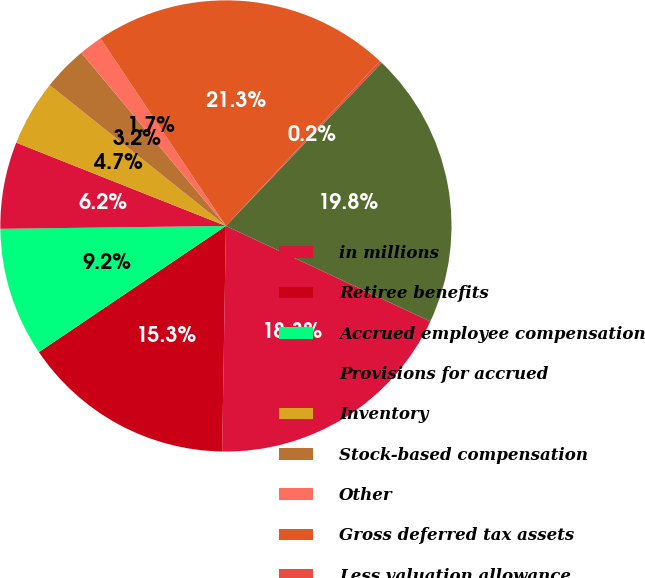Convert chart to OTSL. <chart><loc_0><loc_0><loc_500><loc_500><pie_chart><fcel>in millions<fcel>Retiree benefits<fcel>Accrued employee compensation<fcel>Provisions for accrued<fcel>Inventory<fcel>Stock-based compensation<fcel>Other<fcel>Gross deferred tax assets<fcel>Less valuation allowance<fcel>Net deferred tax assets<nl><fcel>18.31%<fcel>15.29%<fcel>9.24%<fcel>6.22%<fcel>4.71%<fcel>3.2%<fcel>1.69%<fcel>21.33%<fcel>0.18%<fcel>19.82%<nl></chart> 